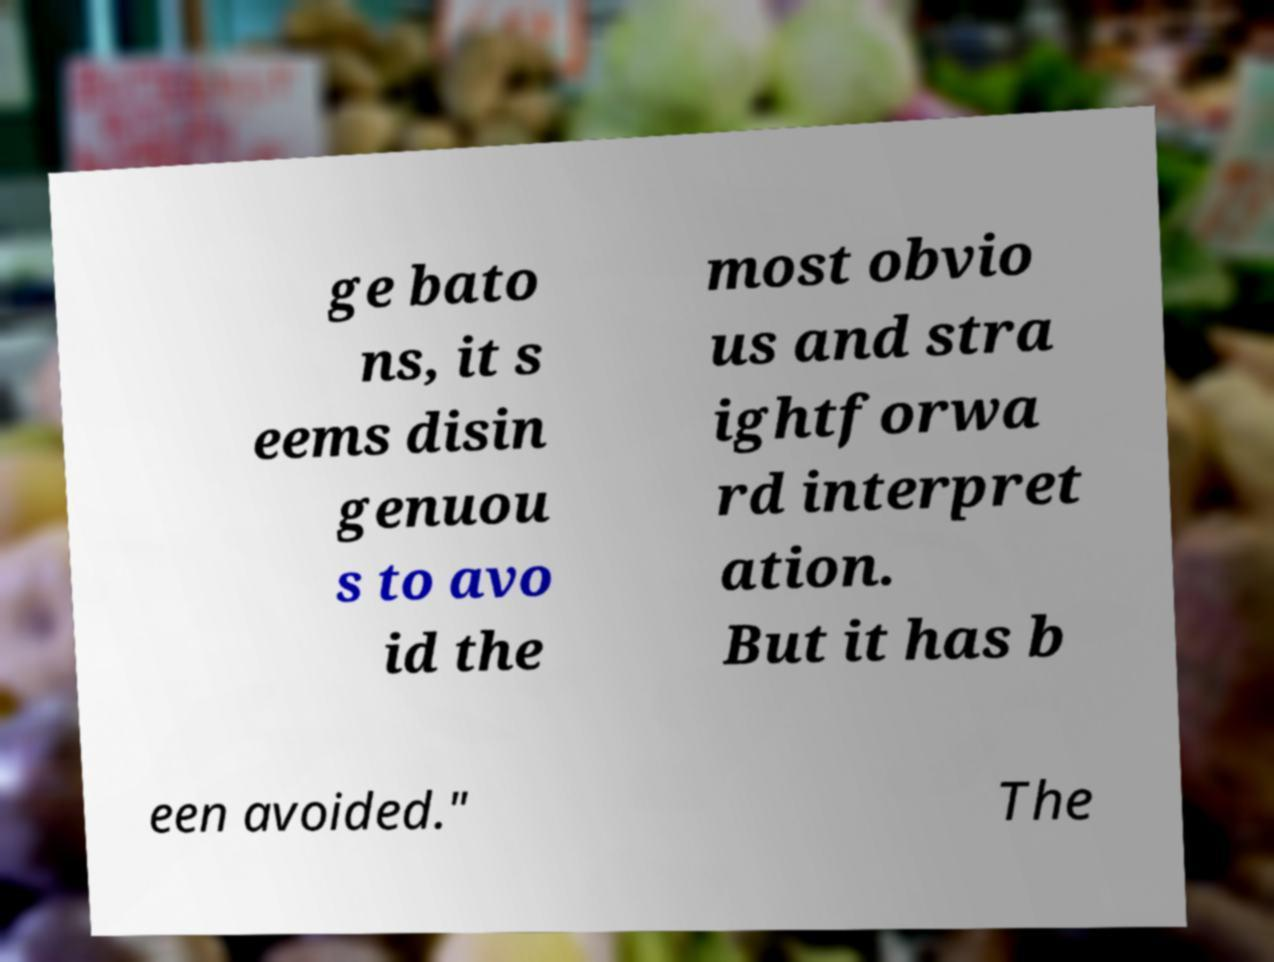I need the written content from this picture converted into text. Can you do that? ge bato ns, it s eems disin genuou s to avo id the most obvio us and stra ightforwa rd interpret ation. But it has b een avoided." The 